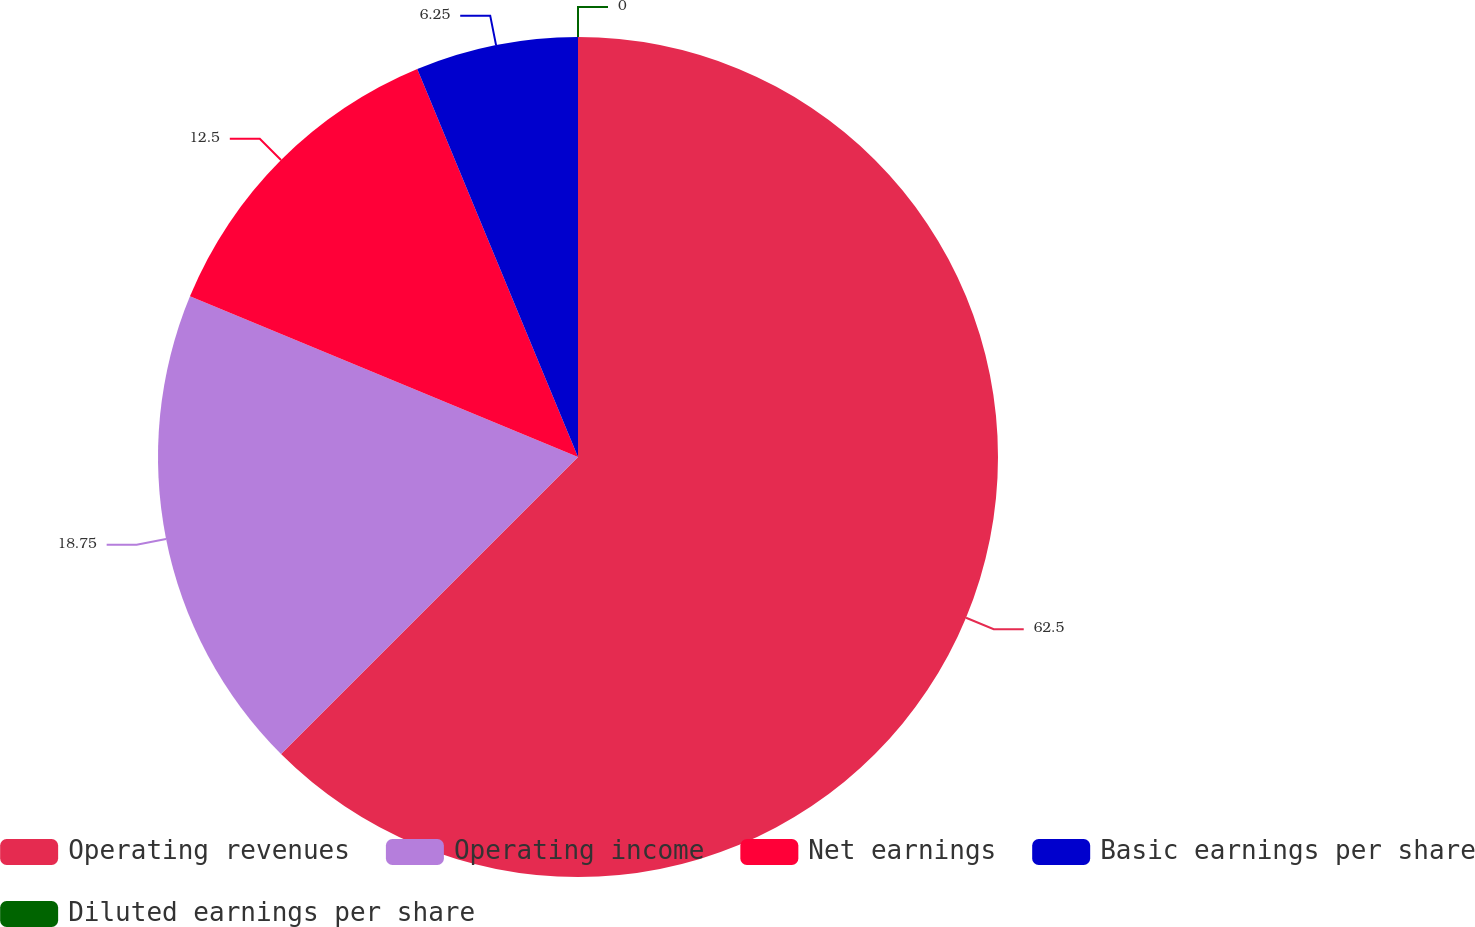<chart> <loc_0><loc_0><loc_500><loc_500><pie_chart><fcel>Operating revenues<fcel>Operating income<fcel>Net earnings<fcel>Basic earnings per share<fcel>Diluted earnings per share<nl><fcel>62.5%<fcel>18.75%<fcel>12.5%<fcel>6.25%<fcel>0.0%<nl></chart> 